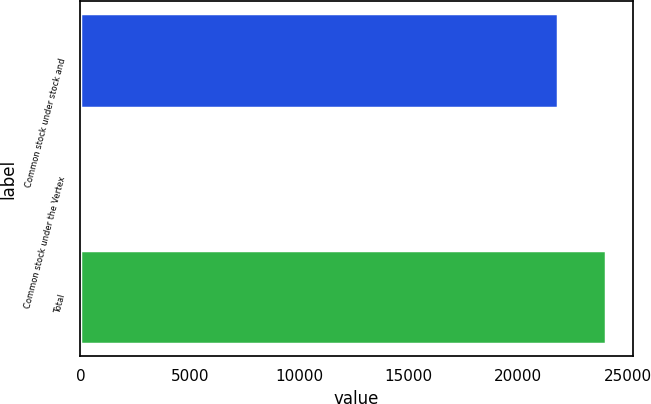<chart> <loc_0><loc_0><loc_500><loc_500><bar_chart><fcel>Common stock under stock and<fcel>Common stock under the Vertex<fcel>Total<nl><fcel>21829<fcel>125<fcel>24036.8<nl></chart> 